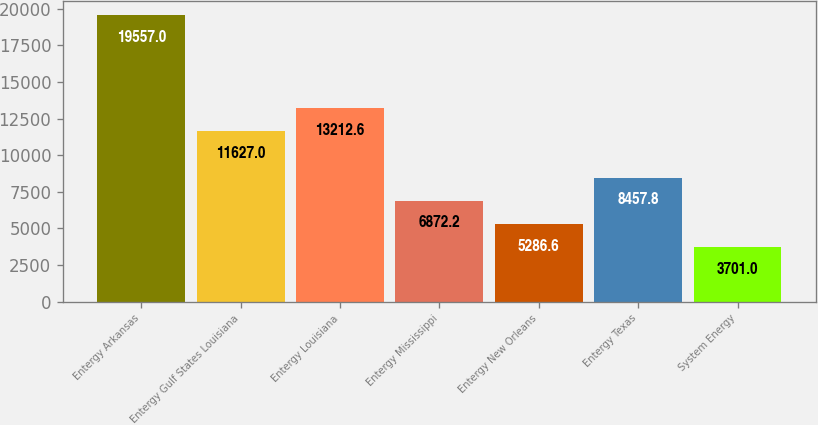Convert chart to OTSL. <chart><loc_0><loc_0><loc_500><loc_500><bar_chart><fcel>Entergy Arkansas<fcel>Entergy Gulf States Louisiana<fcel>Entergy Louisiana<fcel>Entergy Mississippi<fcel>Entergy New Orleans<fcel>Entergy Texas<fcel>System Energy<nl><fcel>19557<fcel>11627<fcel>13212.6<fcel>6872.2<fcel>5286.6<fcel>8457.8<fcel>3701<nl></chart> 